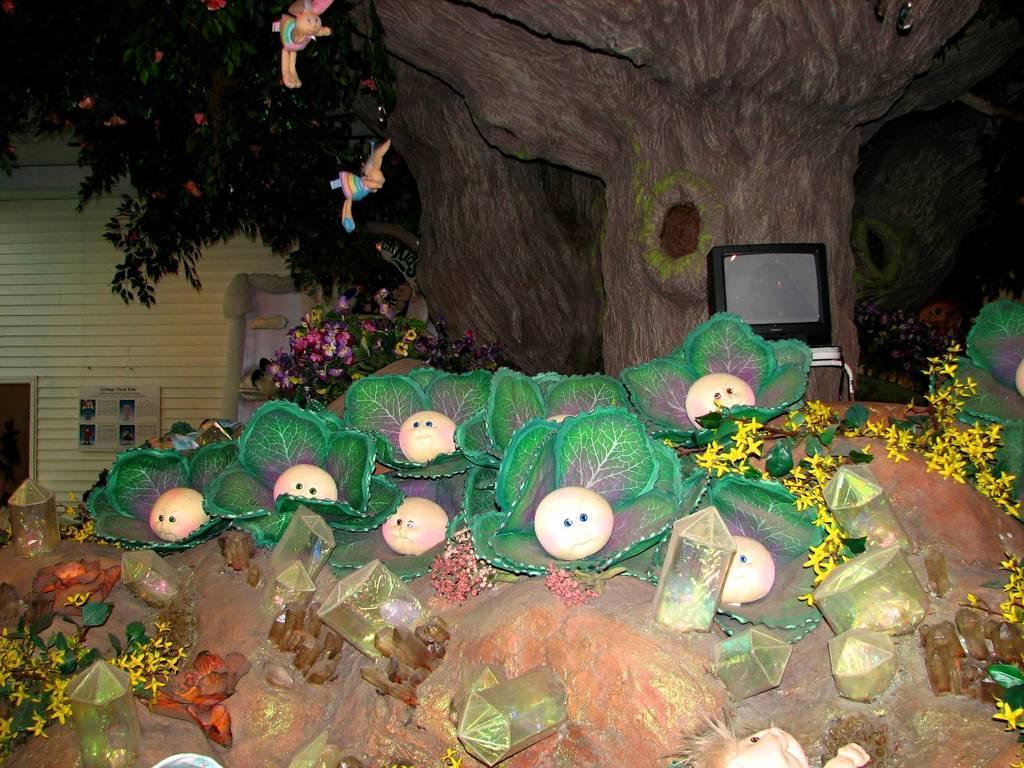How would you summarize this image in a sentence or two? In this image there is a tree. At the bottom there is a rock and we can see leaves, flowers and some decors placed on the rock. In the background there is a building. On the right there is a television placed on the stand and there are dolls. 